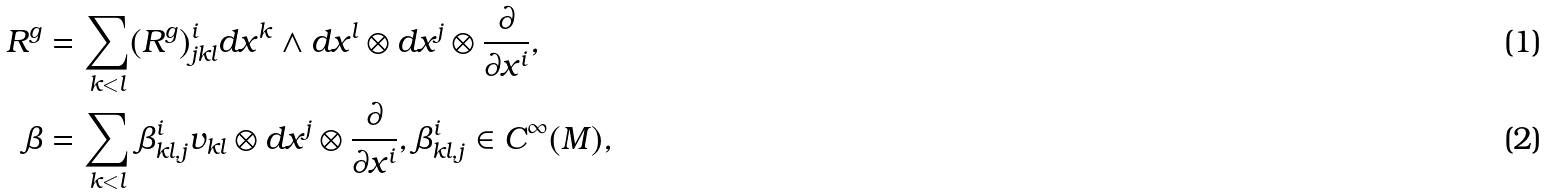<formula> <loc_0><loc_0><loc_500><loc_500>R ^ { g } & = \sum _ { k < l } ( R ^ { g } ) _ { j k l } ^ { i } d x ^ { k } \wedge d x ^ { l } \otimes d x ^ { j } \otimes \frac { \partial } { \partial x ^ { i } } , \\ \beta & = \sum _ { k < l } \beta _ { k l , j } ^ { i } v _ { k l } \otimes d x ^ { j } \otimes \frac { \partial } { \partial x ^ { i } } , \beta _ { k l , j } ^ { i } \in C ^ { \infty } ( M ) ,</formula> 